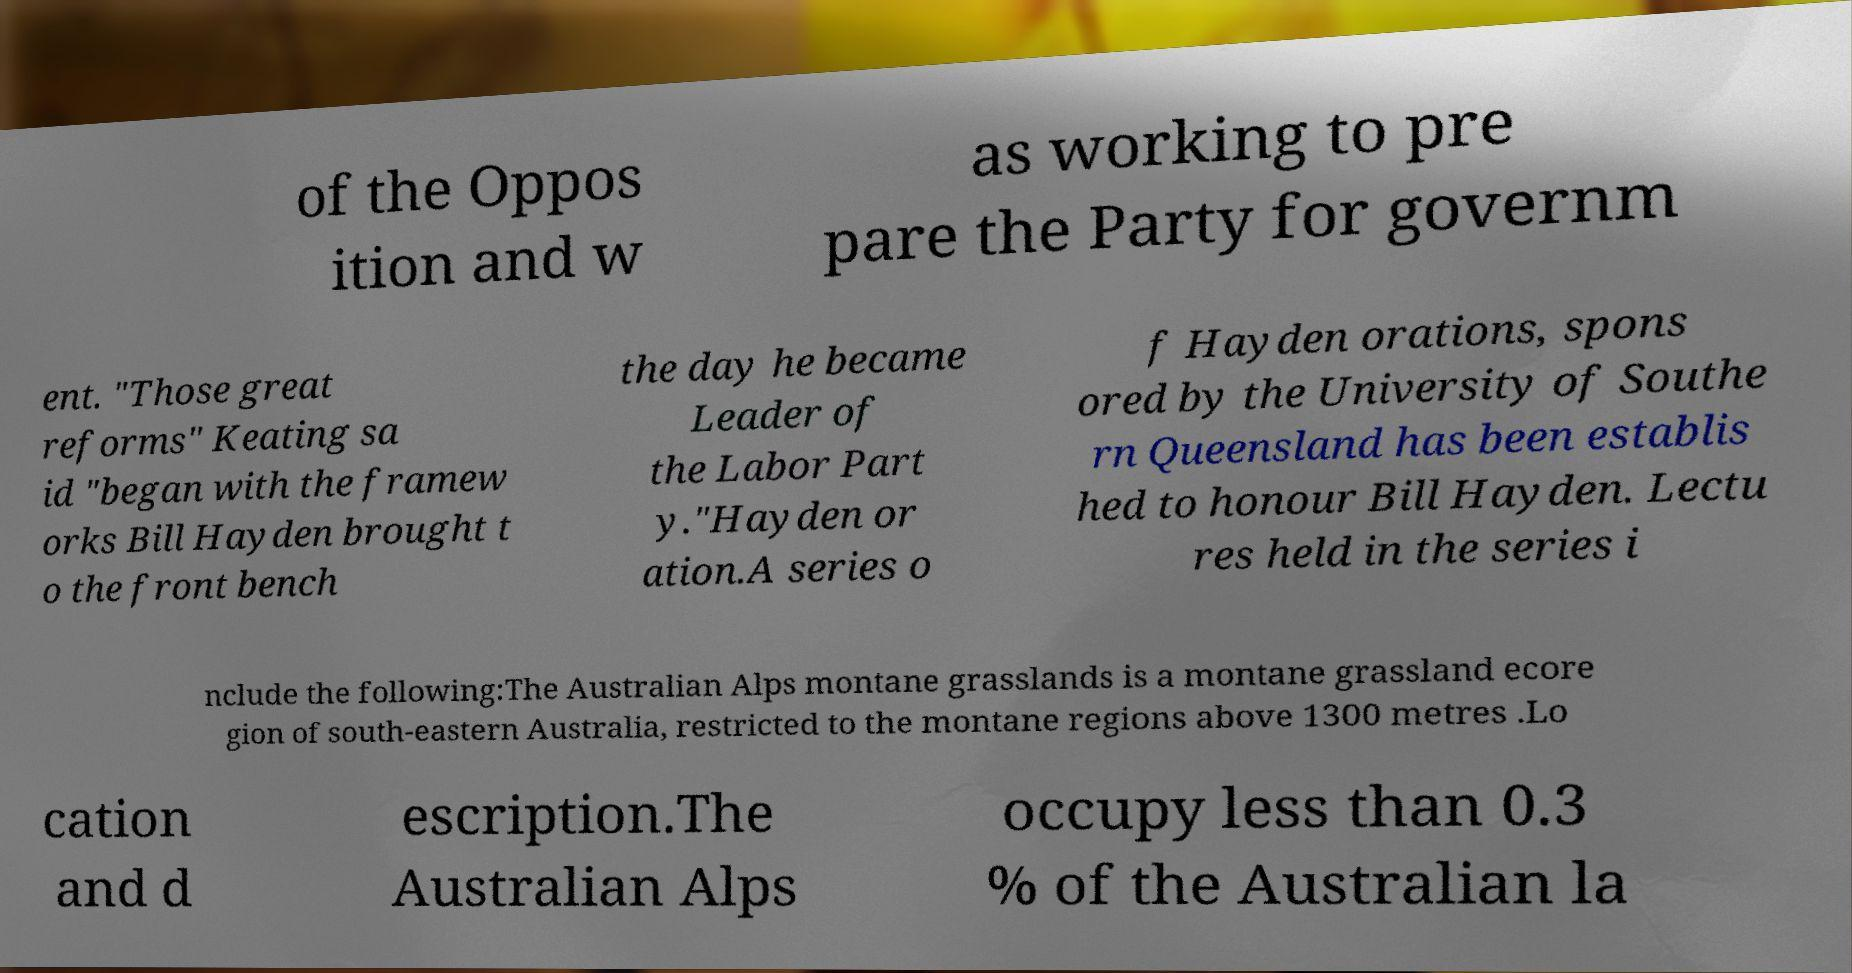Please identify and transcribe the text found in this image. of the Oppos ition and w as working to pre pare the Party for governm ent. "Those great reforms" Keating sa id "began with the framew orks Bill Hayden brought t o the front bench the day he became Leader of the Labor Part y."Hayden or ation.A series o f Hayden orations, spons ored by the University of Southe rn Queensland has been establis hed to honour Bill Hayden. Lectu res held in the series i nclude the following:The Australian Alps montane grasslands is a montane grassland ecore gion of south-eastern Australia, restricted to the montane regions above 1300 metres .Lo cation and d escription.The Australian Alps occupy less than 0.3 % of the Australian la 